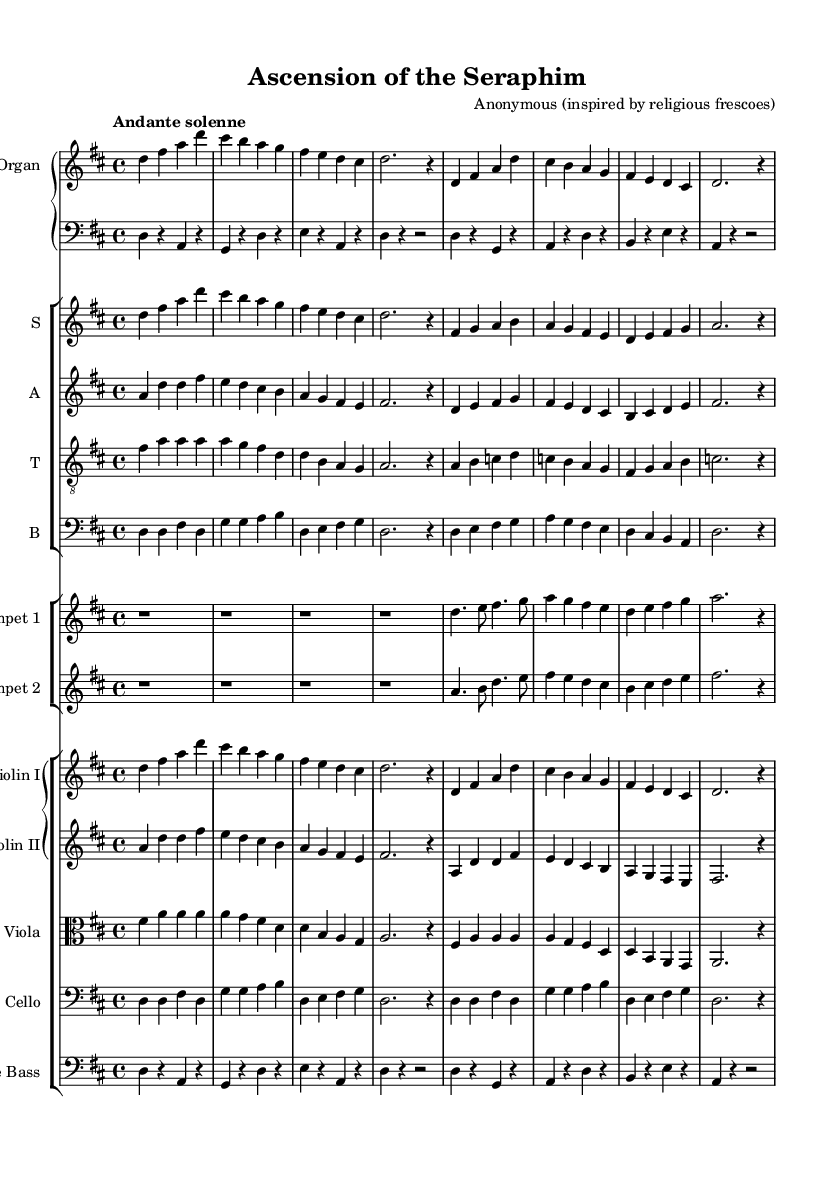What is the key signature of this music? The key signature indicates D major, which has two sharps (F# and C#). This can be identified by observing the key signature at the beginning of the staff.
Answer: D major What is the time signature of this music? The time signature is 4/4, which represents four beats per measure and is visible at the beginning of the score.
Answer: 4/4 What is the tempo marking for this piece? The tempo marking states "Andante solenne," which suggests a moderate tempo, typically around 76 to 108 beats per minute. It is located at the beginning near the time signature.
Answer: Andante solenne How many staves are used for the choir? There are four staves used for the choir, each representing different vocal parts: sopranos, altos, tenors, and basses. This can be seen in the choir staff section of the sheet music.
Answer: Four Which instruments are featured in this arrangement? The featured instruments include organ, choir (soprano, alto, tenor, bass), trumpet, violin, viola, cello, and double bass. This can be identified by the instrument names at the beginning of each staff.
Answer: Organ, choir, trumpet, violin, viola, cello, double bass What is the texture of this Baroque piece? The texture is polyphonic, as multiple independent melodies are sung or played simultaneously, characteristic of Baroque music. This can be inferred from the interplay between voices and instruments.
Answer: Polyphonic Is there a prominent use of counterpoint in this music? Yes, counterpoint is prominently used as different melodic lines interact with each other, creating a complex and interwoven texture typical in Baroque compositions. This is evident from the distinct lines in the various voices.
Answer: Yes 